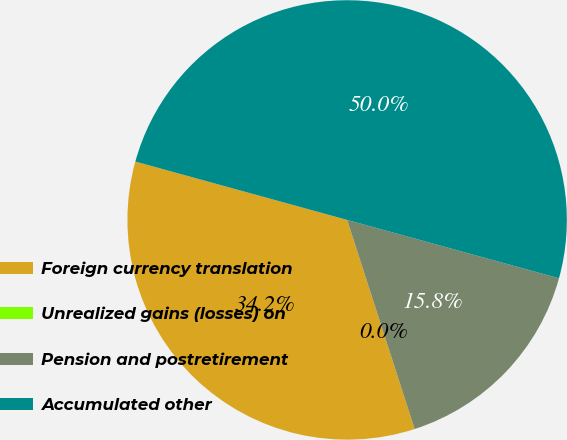<chart> <loc_0><loc_0><loc_500><loc_500><pie_chart><fcel>Foreign currency translation<fcel>Unrealized gains (losses) on<fcel>Pension and postretirement<fcel>Accumulated other<nl><fcel>34.25%<fcel>0.0%<fcel>15.75%<fcel>50.0%<nl></chart> 